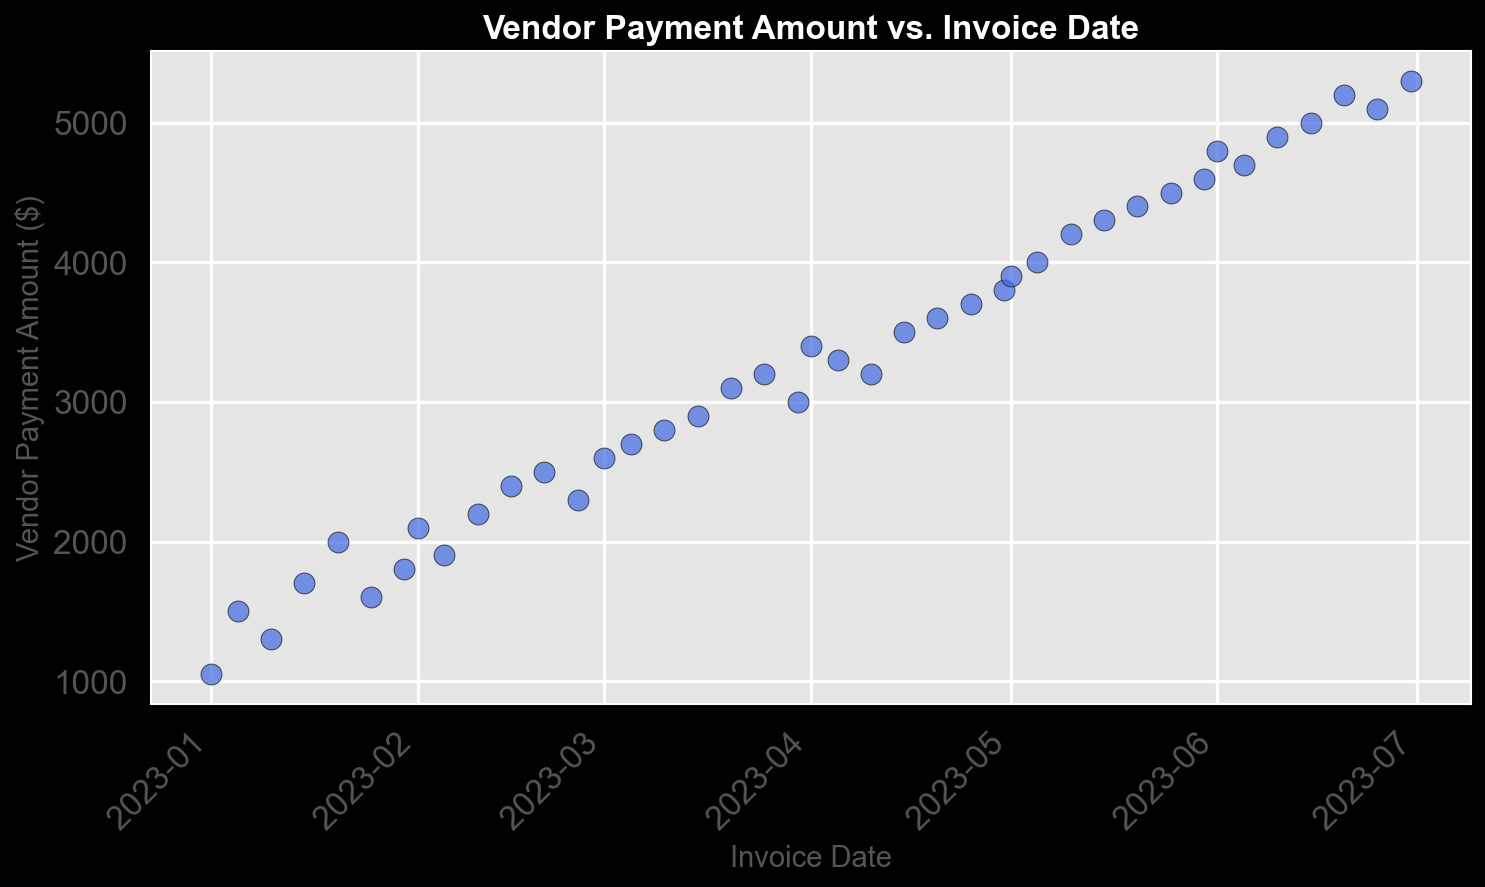What trend do you observe in vendor payment amounts over time? The points on the scatter plot show an increasing trend over the months, indicating that vendor payment amounts generally increased over time.
Answer: Increasing Which month shows the highest overall vendor payment amounts? By examining the scatter plot, June has the highest vendor payment amounts, with significant data points higher than other months.
Answer: June What is the approximate vendor payment amount on March 15, 2023? Locating the data point corresponding to March 15, the vendor payment amount appears to be about $2900.
Answer: $2900 How much did the vendor payment amount increase from January 1, 2023, to June 30, 2023? Comparing the data points, January 1 has a payment of $1050, and June 30 has a payment of $5300. The increase is $5300 - $1050.
Answer: $4250 Which date has the lowest vendor payment amount, and what is the amount? The earliest date, January 1, has the lowest payment amount among the points, which is $1050.
Answer: January 1, $1050 On which dates close to March 1, 2023, were vendor payments made, and what were the amounts? Observing the dates near March 1, payments on March 1, March 5, and March 10 were approximately $2600, $2700, and $2800 respectively.
Answer: March 1: $2600, March 5: $2700, March 10: $2800 Between April 1 and May 10, what is the average vendor payment amount? For April 1 to May 10, data points and their amounts are: April 1 ($3400), April 5 ($3300), April 10 ($3200), April 15 ($3500), April 20 ($3600), April 25 ($3700), April 30 ($3800), May 1 ($3900), May 5 ($4000), May 10 ($4200). The average is calculated by summing these values and dividing by the number of points.
Answer: $3620 If we consider a significant spike/payment to be above $5000, on what date(s) does this occur? A review of the data indicates that payments surpassing $5000 occur on June 10, June 15, June 20, June 25, and June 30.
Answer: June 10, June 15, June 20, June 25, June 30 Which is larger - the vendor payment on February 15, 2023, or March 15, 2023? Referring to the respective dates, February 15 has a payment amount of $2400, while March 15 has $2900. March 15 is thus larger.
Answer: March 15 What is the difference between the highest vendor payment in May and the lowest vendor payment in March? The highest payment in May is $4600 (May 30), and the lowest in March is $2600 (March 1). The difference is $4600 - $2600.
Answer: $2000 